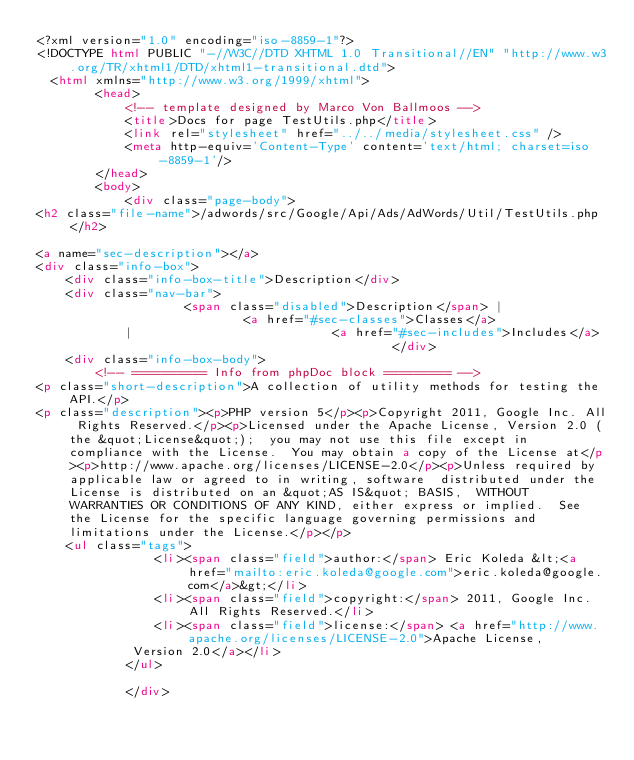Convert code to text. <code><loc_0><loc_0><loc_500><loc_500><_HTML_><?xml version="1.0" encoding="iso-8859-1"?>
<!DOCTYPE html PUBLIC "-//W3C//DTD XHTML 1.0 Transitional//EN" "http://www.w3.org/TR/xhtml1/DTD/xhtml1-transitional.dtd">
  <html xmlns="http://www.w3.org/1999/xhtml">
		<head>
			<!-- template designed by Marco Von Ballmoos -->
			<title>Docs for page TestUtils.php</title>
			<link rel="stylesheet" href="../../media/stylesheet.css" />
			<meta http-equiv='Content-Type' content='text/html; charset=iso-8859-1'/>
		</head>
		<body>
			<div class="page-body">			
<h2 class="file-name">/adwords/src/Google/Api/Ads/AdWords/Util/TestUtils.php</h2>

<a name="sec-description"></a>
<div class="info-box">
	<div class="info-box-title">Description</div>
	<div class="nav-bar">
					<span class="disabled">Description</span> |
							<a href="#sec-classes">Classes</a>
			|							<a href="#sec-includes">Includes</a>
												</div>
	<div class="info-box-body">	
		<!-- ========== Info from phpDoc block ========= -->
<p class="short-description">A collection of utility methods for testing the API.</p>
<p class="description"><p>PHP version 5</p><p>Copyright 2011, Google Inc. All Rights Reserved.</p><p>Licensed under the Apache License, Version 2.0 (the &quot;License&quot;);  you may not use this file except in compliance with the License.  You may obtain a copy of the License at</p><p>http://www.apache.org/licenses/LICENSE-2.0</p><p>Unless required by applicable law or agreed to in writing, software  distributed under the License is distributed on an &quot;AS IS&quot; BASIS,  WITHOUT WARRANTIES OR CONDITIONS OF ANY KIND, either express or implied.  See the License for the specific language governing permissions and  limitations under the License.</p></p>
	<ul class="tags">
				<li><span class="field">author:</span> Eric Koleda &lt;<a href="mailto:eric.koleda@google.com">eric.koleda@google.com</a>&gt;</li>
				<li><span class="field">copyright:</span> 2011, Google Inc. All Rights Reserved.</li>
				<li><span class="field">license:</span> <a href="http://www.apache.org/licenses/LICENSE-2.0">Apache License,
             Version 2.0</a></li>
			</ul>
		
			</div></code> 